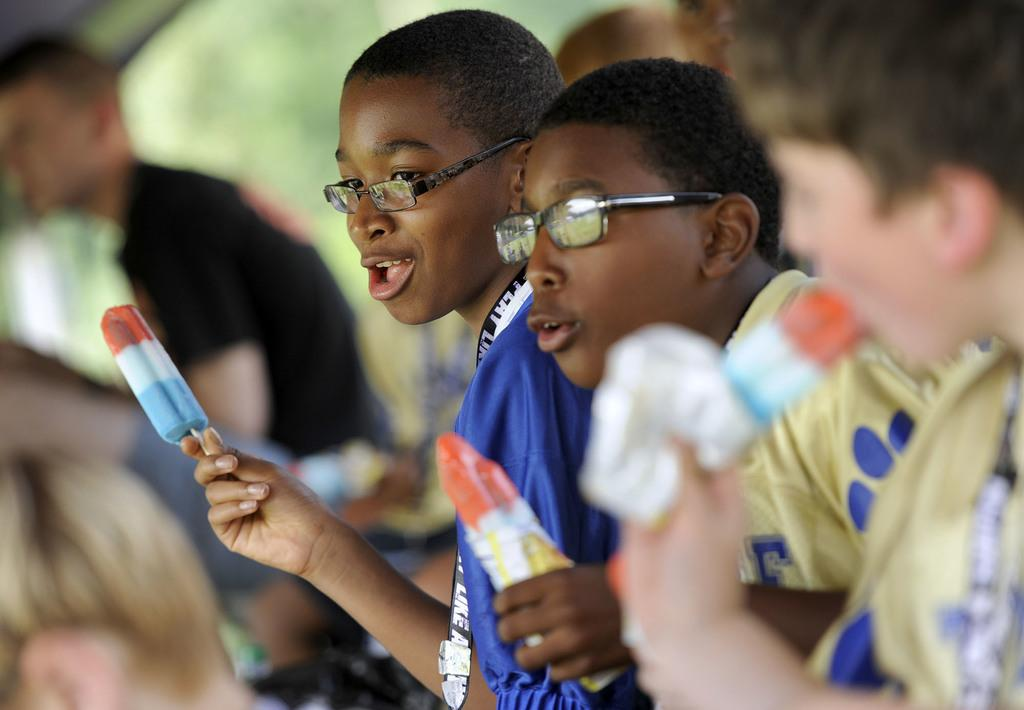How many boys are present in the image? There are boys in the image, but the exact number is not specified. What are the boys holding in their hands? The boys are holding ice cream in their hands. What type of grape can be seen on the canvas in the image? There is no canvas or grape present in the image; it features boys holding ice cream. 